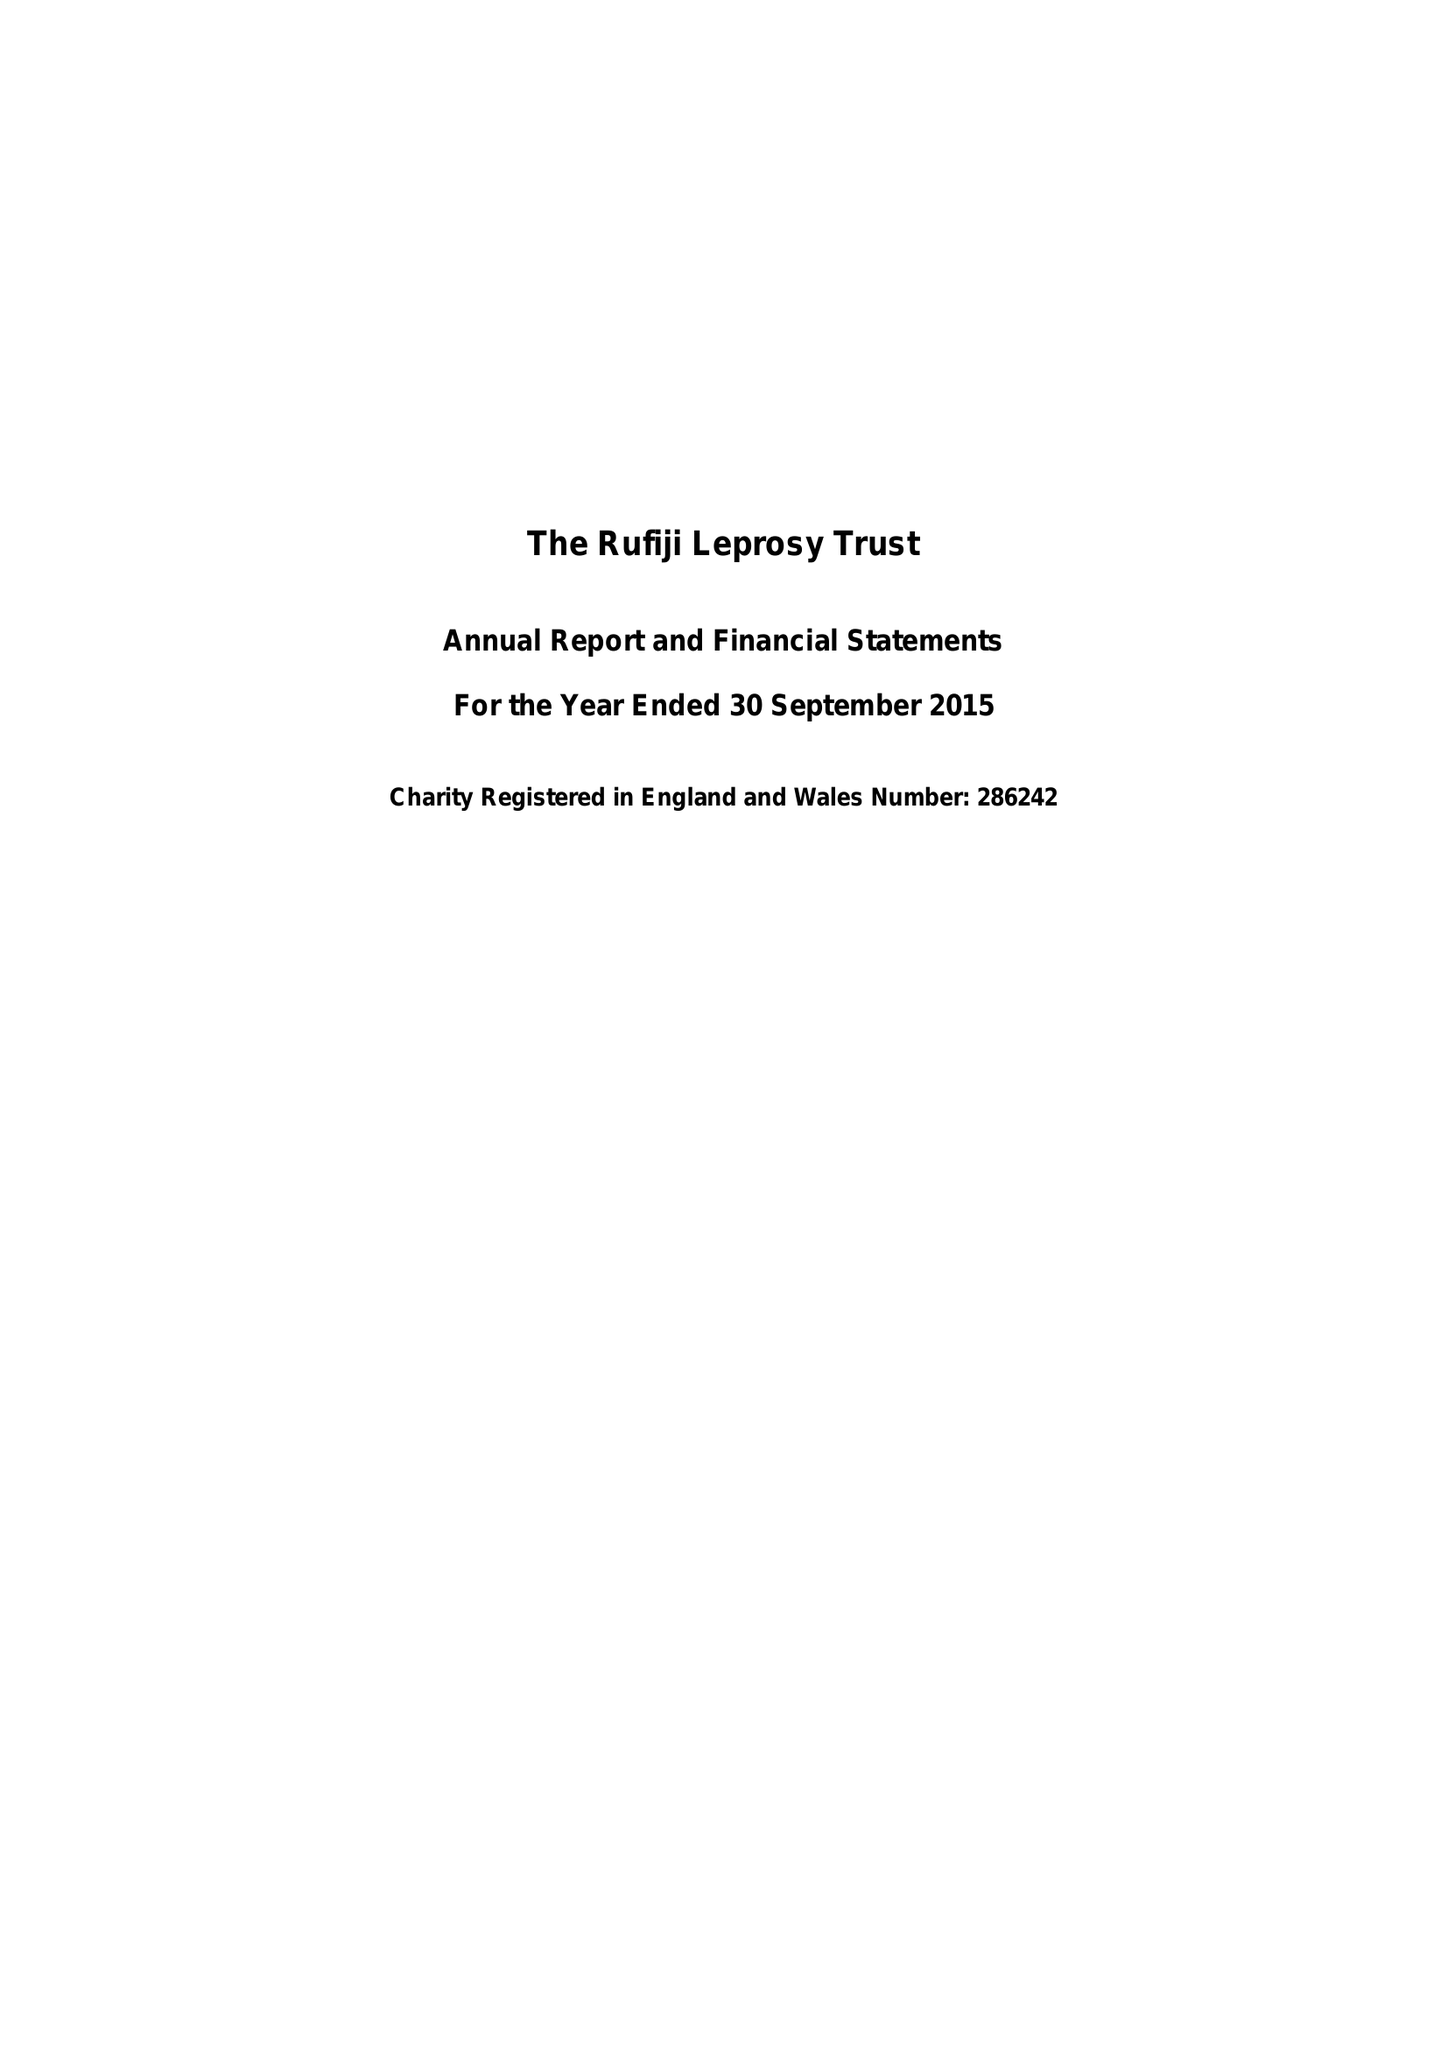What is the value for the charity_number?
Answer the question using a single word or phrase. 286242 